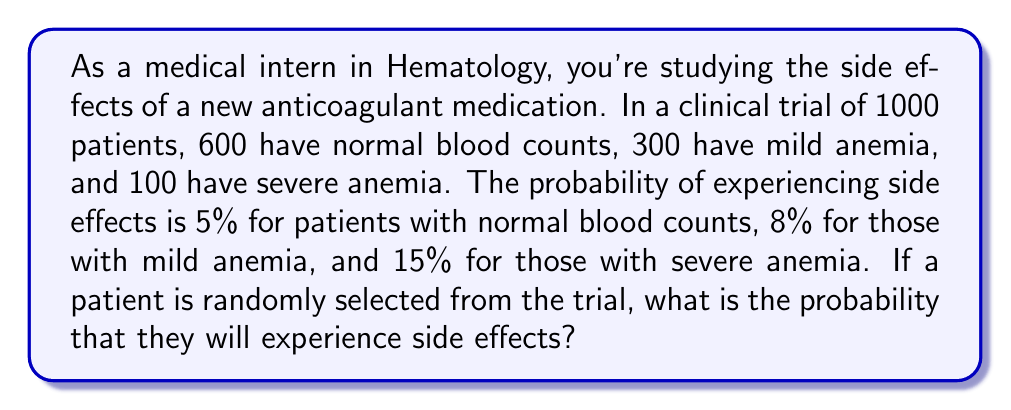Can you answer this question? Let's approach this step-by-step using the law of total probability:

1) Define events:
   A: Patient experiences side effects
   N: Patient has normal blood count
   M: Patient has mild anemia
   S: Patient has severe anemia

2) Given probabilities:
   $P(N) = \frac{600}{1000} = 0.6$
   $P(M) = \frac{300}{1000} = 0.3$
   $P(S) = \frac{100}{1000} = 0.1$
   $P(A|N) = 0.05$
   $P(A|M) = 0.08$
   $P(A|S) = 0.15$

3) Apply the law of total probability:
   $$P(A) = P(A|N)P(N) + P(A|M)P(M) + P(A|S)P(S)$$

4) Substitute the values:
   $$P(A) = (0.05)(0.6) + (0.08)(0.3) + (0.15)(0.1)$$

5) Calculate:
   $$P(A) = 0.03 + 0.024 + 0.015 = 0.069$$

Therefore, the probability that a randomly selected patient will experience side effects is 0.069 or 6.9%.
Answer: 0.069 